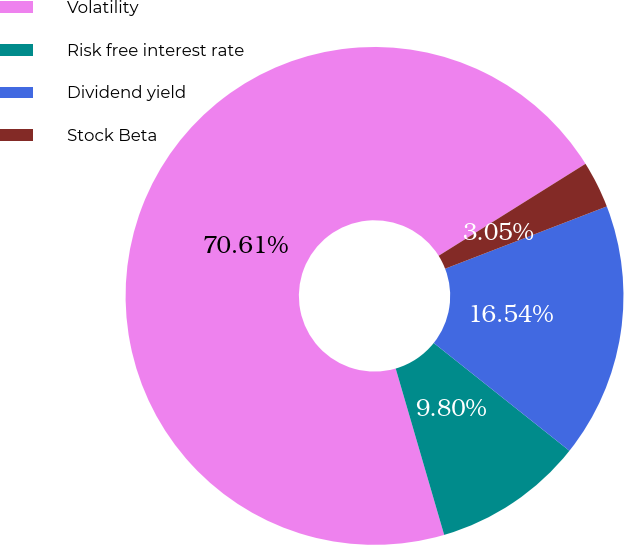Convert chart. <chart><loc_0><loc_0><loc_500><loc_500><pie_chart><fcel>Volatility<fcel>Risk free interest rate<fcel>Dividend yield<fcel>Stock Beta<nl><fcel>70.61%<fcel>9.8%<fcel>16.54%<fcel>3.05%<nl></chart> 